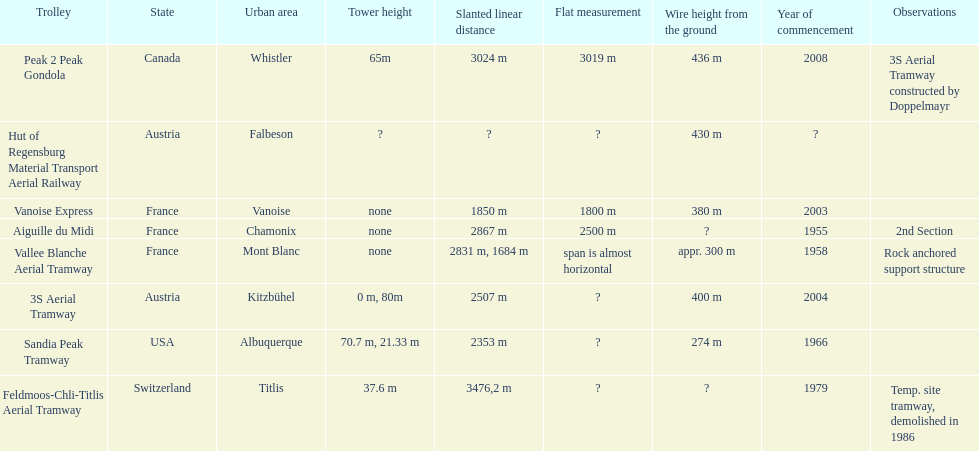At least how many aerial tramways were inaugurated after 1970? 4. 